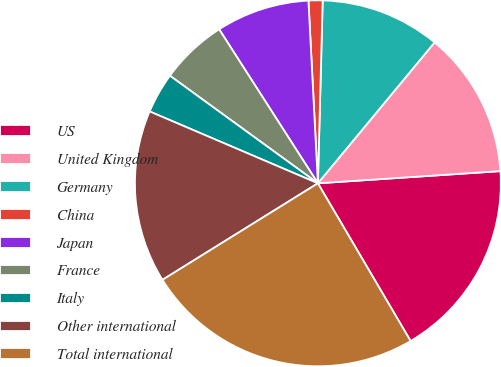<chart> <loc_0><loc_0><loc_500><loc_500><pie_chart><fcel>US<fcel>United Kingdom<fcel>Germany<fcel>China<fcel>Japan<fcel>France<fcel>Italy<fcel>Other international<fcel>Total international<nl><fcel>17.6%<fcel>12.93%<fcel>10.59%<fcel>1.24%<fcel>8.25%<fcel>5.92%<fcel>3.58%<fcel>15.27%<fcel>24.61%<nl></chart> 